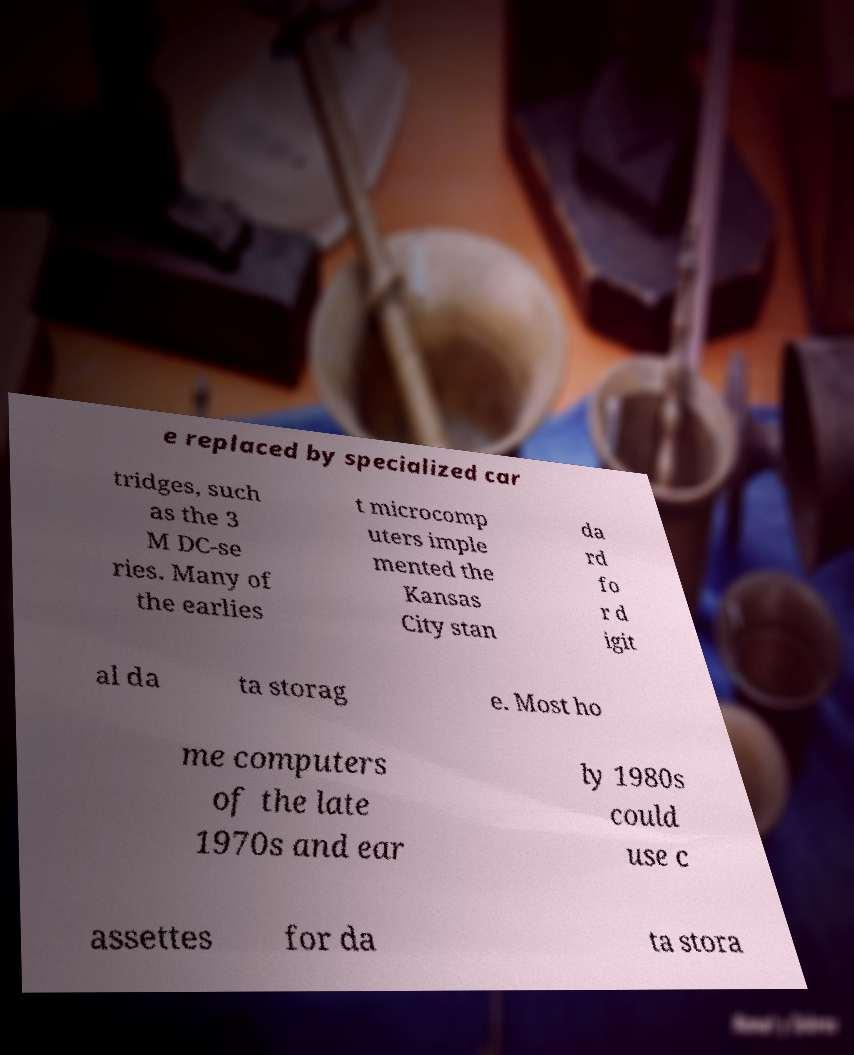For documentation purposes, I need the text within this image transcribed. Could you provide that? e replaced by specialized car tridges, such as the 3 M DC-se ries. Many of the earlies t microcomp uters imple mented the Kansas City stan da rd fo r d igit al da ta storag e. Most ho me computers of the late 1970s and ear ly 1980s could use c assettes for da ta stora 